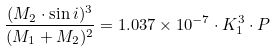<formula> <loc_0><loc_0><loc_500><loc_500>\frac { ( M _ { 2 } \cdot \sin i ) ^ { 3 } } { ( M _ { 1 } + M _ { 2 } ) ^ { 2 } } = 1 . 0 3 7 \times 1 0 ^ { - 7 } \cdot K _ { 1 } ^ { 3 } \cdot P</formula> 